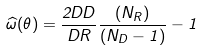Convert formula to latex. <formula><loc_0><loc_0><loc_500><loc_500>\widehat { \omega } ( \theta ) = \frac { 2 D D } { D R } \frac { ( N _ { R } ) } { ( N _ { D } - 1 ) } - 1</formula> 